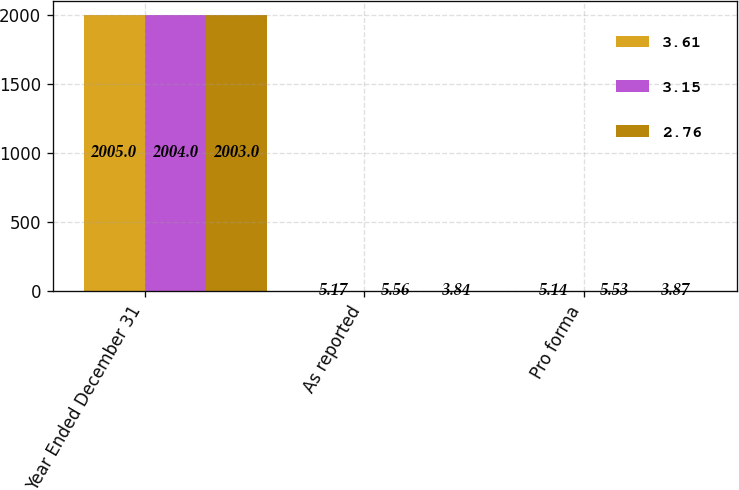<chart> <loc_0><loc_0><loc_500><loc_500><stacked_bar_chart><ecel><fcel>Year Ended December 31<fcel>As reported<fcel>Pro forma<nl><fcel>3.61<fcel>2005<fcel>5.17<fcel>5.14<nl><fcel>3.15<fcel>2004<fcel>5.56<fcel>5.53<nl><fcel>2.76<fcel>2003<fcel>3.84<fcel>3.87<nl></chart> 